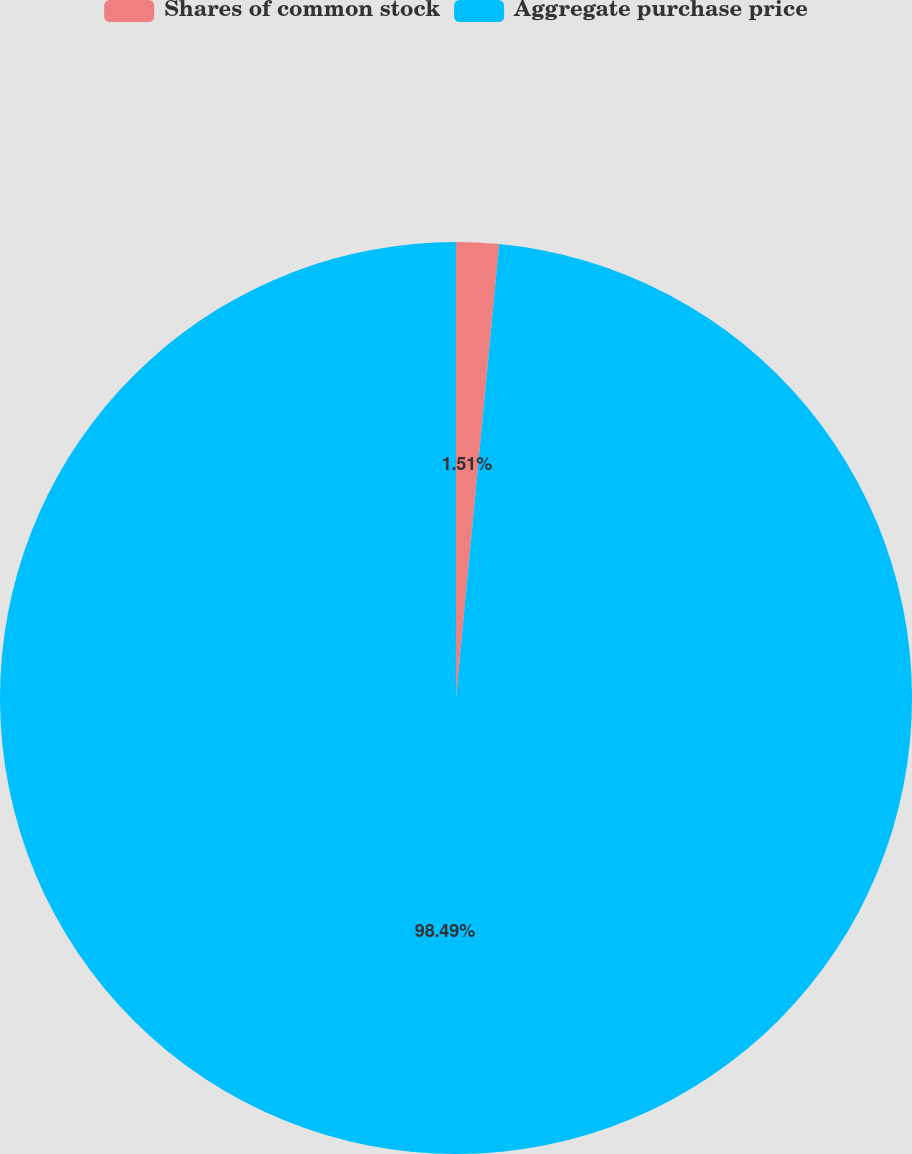Convert chart to OTSL. <chart><loc_0><loc_0><loc_500><loc_500><pie_chart><fcel>Shares of common stock<fcel>Aggregate purchase price<nl><fcel>1.51%<fcel>98.49%<nl></chart> 